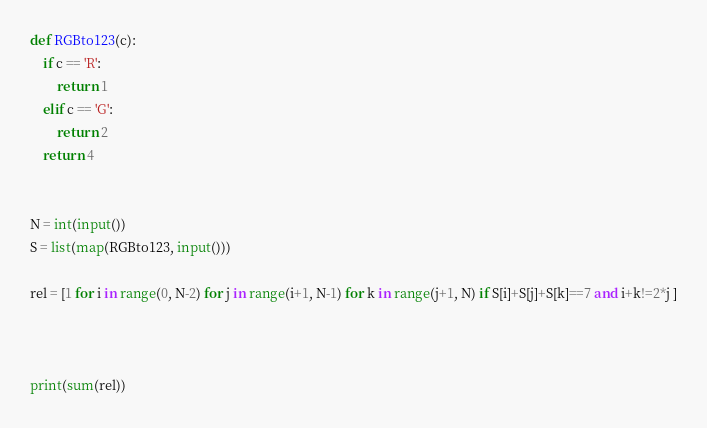<code> <loc_0><loc_0><loc_500><loc_500><_Python_>def RGBto123(c):
    if c == 'R':
        return 1
    elif c == 'G':
        return 2
    return 4


N = int(input())
S = list(map(RGBto123, input()))

rel = [1 for i in range(0, N-2) for j in range(i+1, N-1) for k in range(j+1, N) if S[i]+S[j]+S[k]==7 and i+k!=2*j ]



print(sum(rel))
</code> 